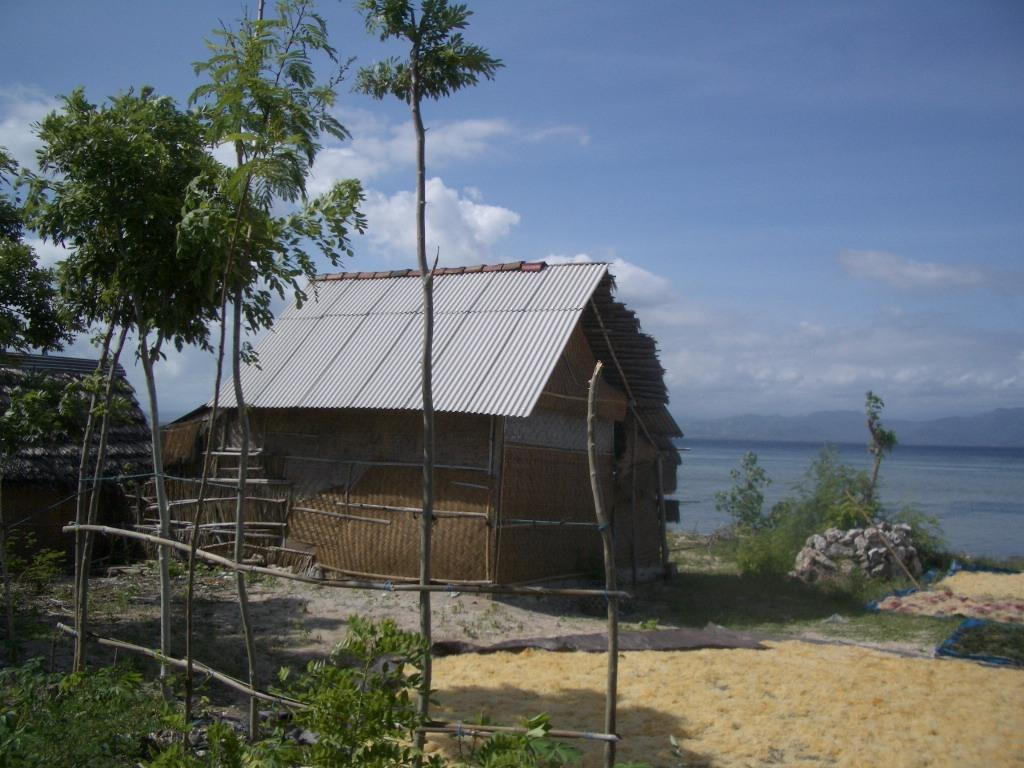What type of vegetation is in the front of the image? There are plants in the front of the image. What other type of vegetation can be seen in the image? There are trees in the image. What structure is located in the center of the image? There is a hut in the center of the image. What can be seen in the background of the image? There is water visible in the background of the image. How would you describe the sky in the image? The sky is cloudy in the image. What type of ring can be seen on the hut in the image? There is no ring present on the hut in the image. How does the salt affect the plants in the image? There is no salt present in the image, so it cannot affect the plants. 